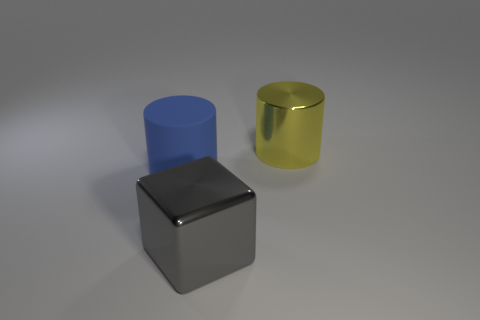Add 2 big purple things. How many objects exist? 5 Subtract all blue cylinders. How many cylinders are left? 1 Add 2 big yellow things. How many big yellow things exist? 3 Subtract 0 cyan balls. How many objects are left? 3 Subtract all cubes. How many objects are left? 2 Subtract all small brown metal spheres. Subtract all yellow metallic objects. How many objects are left? 2 Add 3 big blue cylinders. How many big blue cylinders are left? 4 